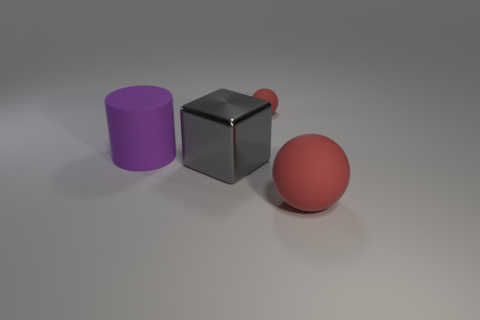Add 4 large shiny things. How many objects exist? 8 Subtract all cylinders. How many objects are left? 3 Subtract all tiny red cylinders. Subtract all red things. How many objects are left? 2 Add 4 red matte objects. How many red matte objects are left? 6 Add 3 big gray metallic cubes. How many big gray metallic cubes exist? 4 Subtract 0 brown cubes. How many objects are left? 4 Subtract all cyan spheres. Subtract all brown blocks. How many spheres are left? 2 